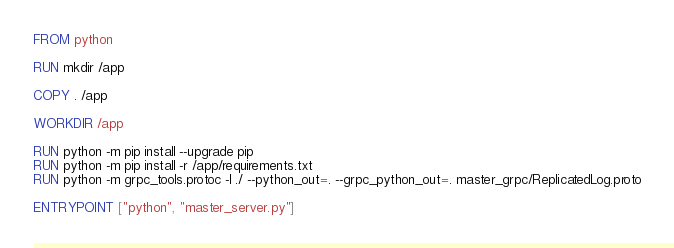Convert code to text. <code><loc_0><loc_0><loc_500><loc_500><_Dockerfile_>FROM python

RUN mkdir /app

COPY . /app

WORKDIR /app

RUN python -m pip install --upgrade pip
RUN python -m pip install -r /app/requirements.txt
RUN python -m grpc_tools.protoc -I ./ --python_out=. --grpc_python_out=. master_grpc/ReplicatedLog.proto

ENTRYPOINT ["python", "master_server.py"]</code> 